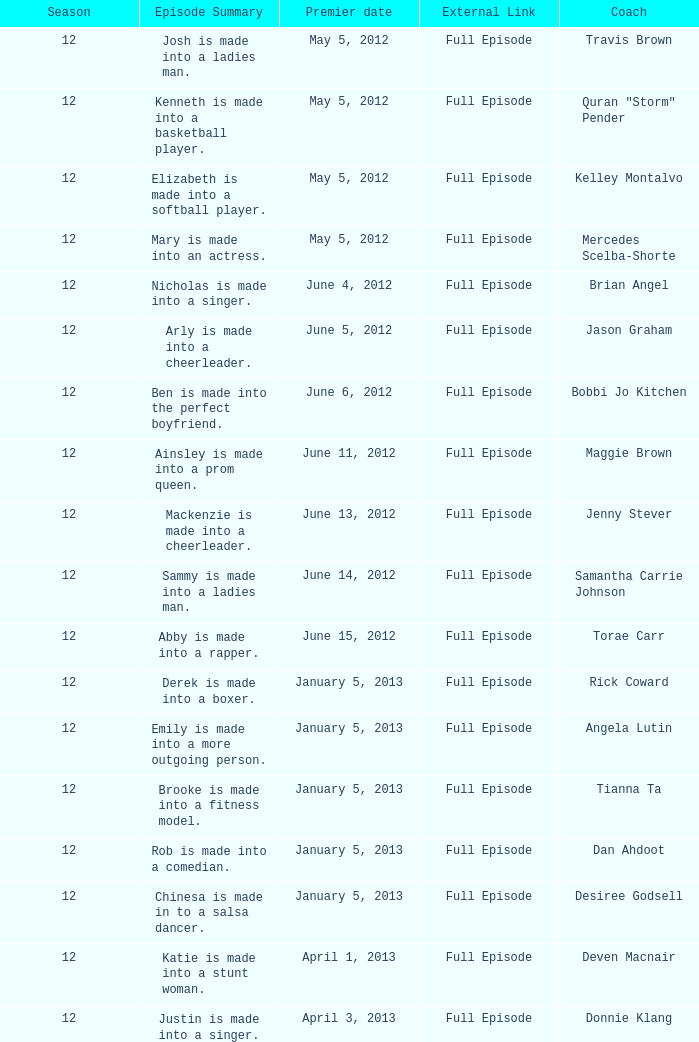Name the episode summary for torae carr Abby is made into a rapper. Write the full table. {'header': ['Season', 'Episode Summary', 'Premier date', 'External Link', 'Coach'], 'rows': [['12', 'Josh is made into a ladies man.', 'May 5, 2012', 'Full Episode', 'Travis Brown'], ['12', 'Kenneth is made into a basketball player.', 'May 5, 2012', 'Full Episode', 'Quran "Storm" Pender'], ['12', 'Elizabeth is made into a softball player.', 'May 5, 2012', 'Full Episode', 'Kelley Montalvo'], ['12', 'Mary is made into an actress.', 'May 5, 2012', 'Full Episode', 'Mercedes Scelba-Shorte'], ['12', 'Nicholas is made into a singer.', 'June 4, 2012', 'Full Episode', 'Brian Angel'], ['12', 'Arly is made into a cheerleader.', 'June 5, 2012', 'Full Episode', 'Jason Graham'], ['12', 'Ben is made into the perfect boyfriend.', 'June 6, 2012', 'Full Episode', 'Bobbi Jo Kitchen'], ['12', 'Ainsley is made into a prom queen.', 'June 11, 2012', 'Full Episode', 'Maggie Brown'], ['12', 'Mackenzie is made into a cheerleader.', 'June 13, 2012', 'Full Episode', 'Jenny Stever'], ['12', 'Sammy is made into a ladies man.', 'June 14, 2012', 'Full Episode', 'Samantha Carrie Johnson'], ['12', 'Abby is made into a rapper.', 'June 15, 2012', 'Full Episode', 'Torae Carr'], ['12', 'Derek is made into a boxer.', 'January 5, 2013', 'Full Episode', 'Rick Coward'], ['12', 'Emily is made into a more outgoing person.', 'January 5, 2013', 'Full Episode', 'Angela Lutin'], ['12', 'Brooke is made into a fitness model.', 'January 5, 2013', 'Full Episode', 'Tianna Ta'], ['12', 'Rob is made into a comedian.', 'January 5, 2013', 'Full Episode', 'Dan Ahdoot'], ['12', 'Chinesa is made in to a salsa dancer.', 'January 5, 2013', 'Full Episode', 'Desiree Godsell'], ['12', 'Katie is made into a stunt woman.', 'April 1, 2013', 'Full Episode', 'Deven Macnair'], ['12', 'Justin is made into a singer.', 'April 3, 2013', 'Full Episode', 'Donnie Klang']]} 